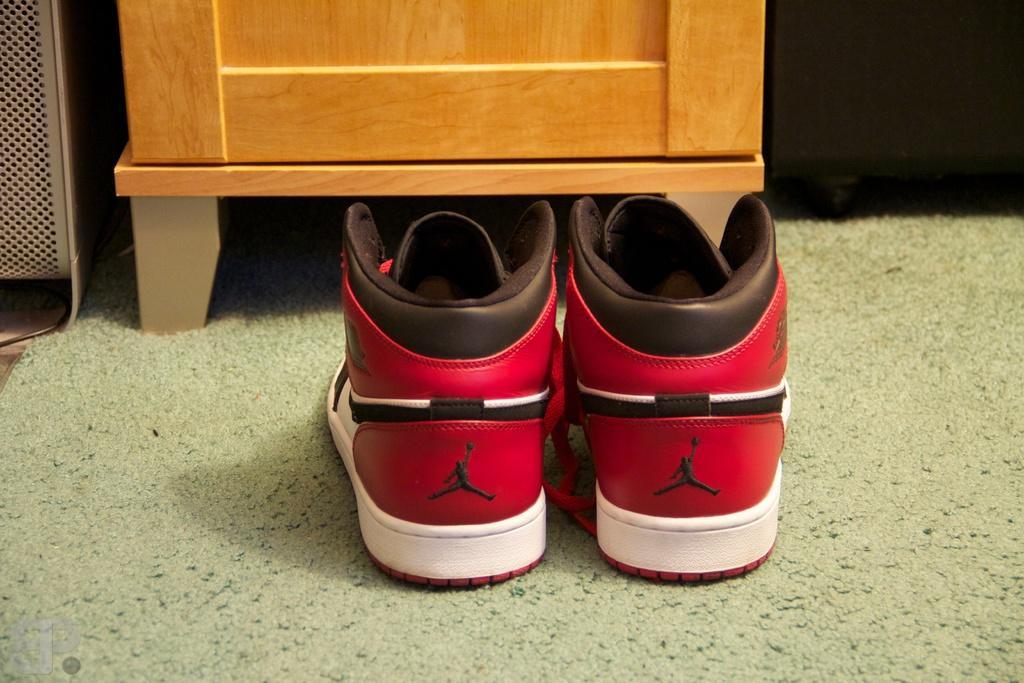Describe this image in one or two sentences. In this image we can see a pair of shoes on the carpet. In the background there are cabinets. 